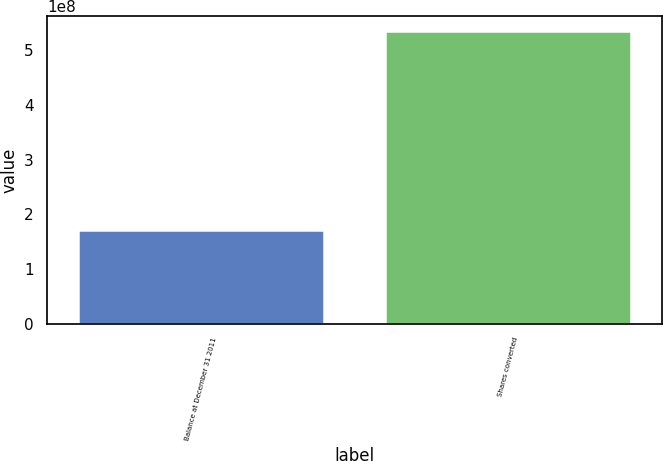Convert chart. <chart><loc_0><loc_0><loc_500><loc_500><bar_chart><fcel>Balance at December 31 2011<fcel>Shares converted<nl><fcel>1.70921e+08<fcel>5.35972e+08<nl></chart> 